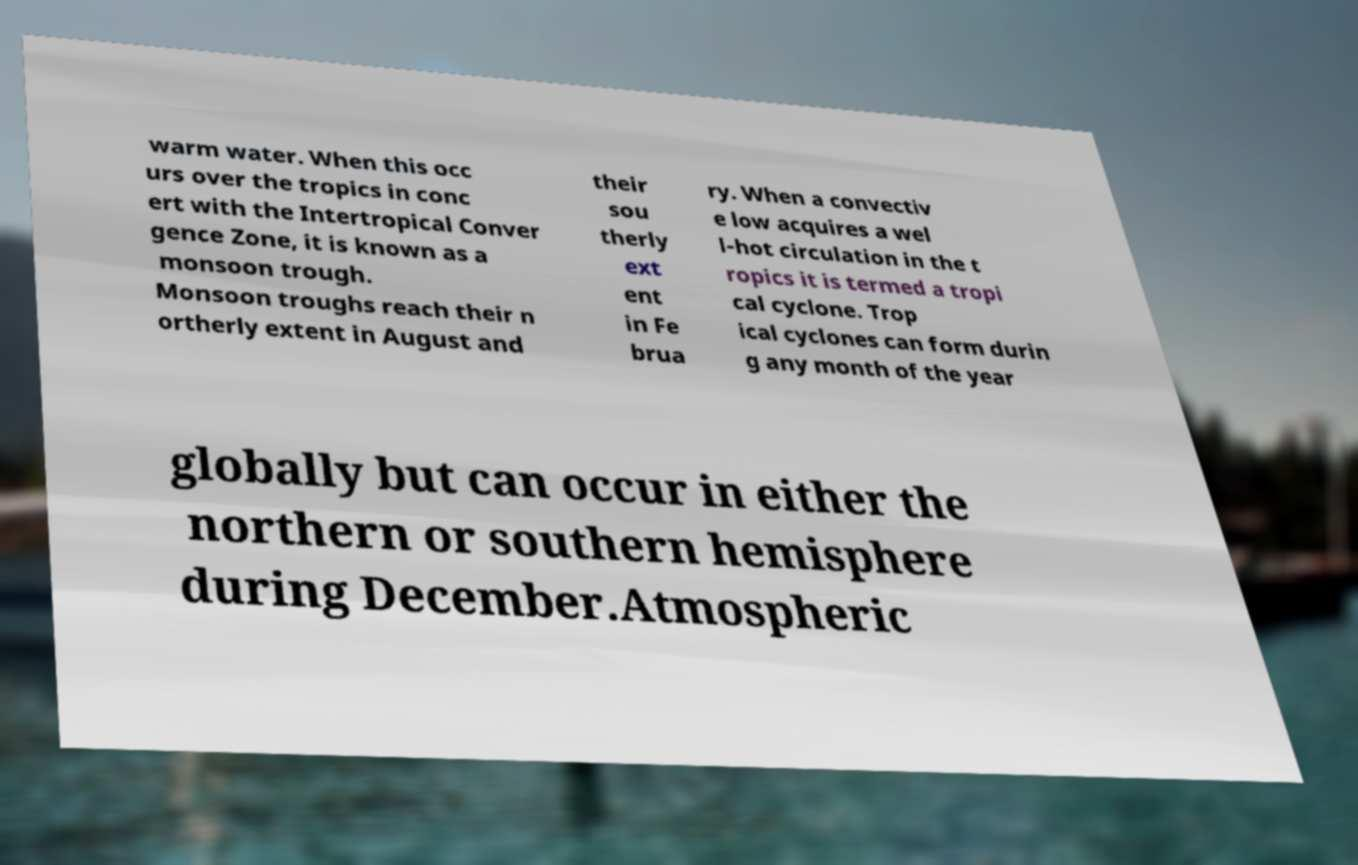Please read and relay the text visible in this image. What does it say? warm water. When this occ urs over the tropics in conc ert with the Intertropical Conver gence Zone, it is known as a monsoon trough. Monsoon troughs reach their n ortherly extent in August and their sou therly ext ent in Fe brua ry. When a convectiv e low acquires a wel l-hot circulation in the t ropics it is termed a tropi cal cyclone. Trop ical cyclones can form durin g any month of the year globally but can occur in either the northern or southern hemisphere during December.Atmospheric 